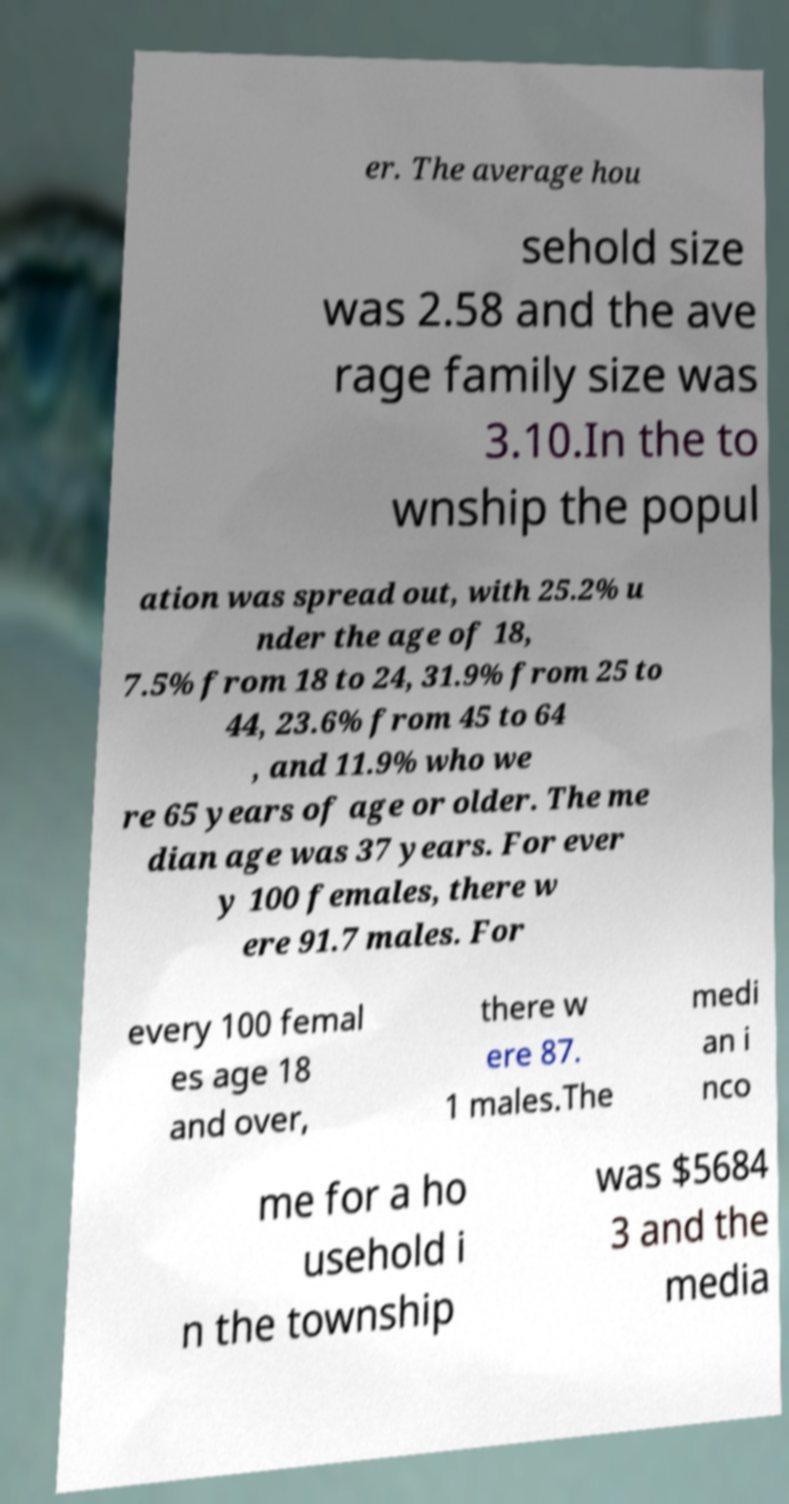Can you read and provide the text displayed in the image?This photo seems to have some interesting text. Can you extract and type it out for me? er. The average hou sehold size was 2.58 and the ave rage family size was 3.10.In the to wnship the popul ation was spread out, with 25.2% u nder the age of 18, 7.5% from 18 to 24, 31.9% from 25 to 44, 23.6% from 45 to 64 , and 11.9% who we re 65 years of age or older. The me dian age was 37 years. For ever y 100 females, there w ere 91.7 males. For every 100 femal es age 18 and over, there w ere 87. 1 males.The medi an i nco me for a ho usehold i n the township was $5684 3 and the media 